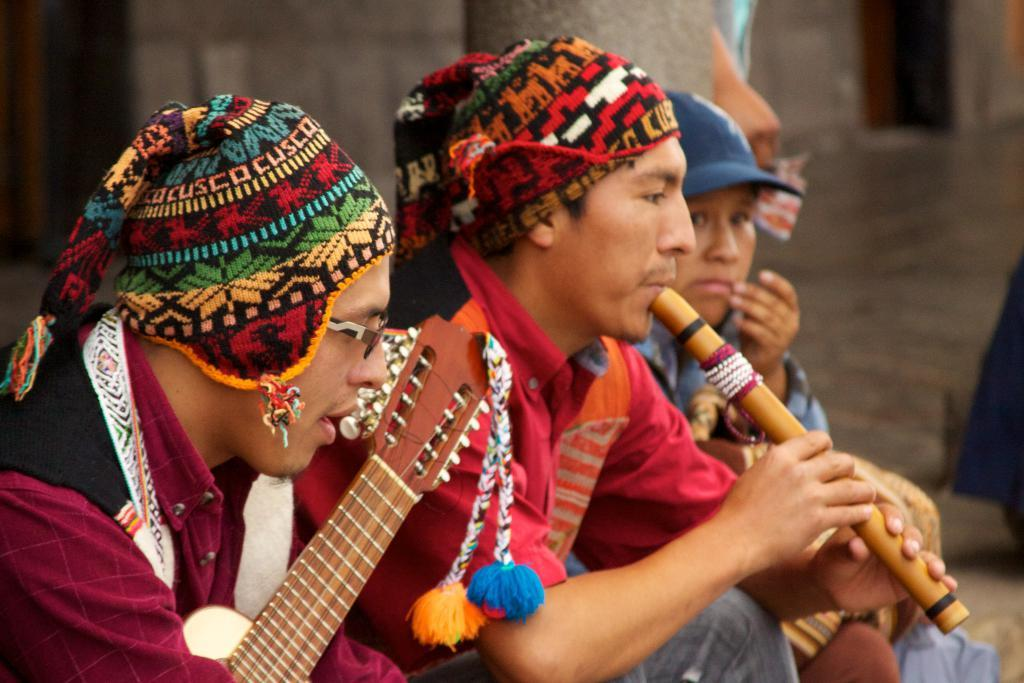How many people are in the image? There are people in the image, but the exact number is not specified. What are the people doing in the image? The people are sitting and holding musical instruments. What can be seen in the background of the image? There is a floor and a wall visible in the background of the image. What is the tendency of the servant in the image? There is no servant present in the image, so it is not possible to determine their tendency. 